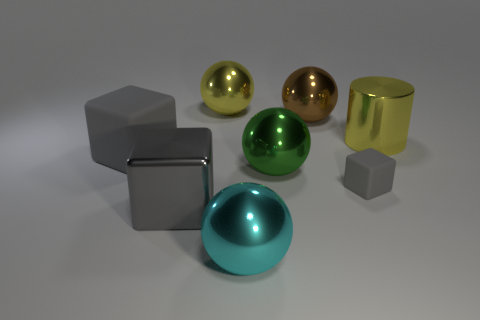How many big metal things are both behind the cyan metal thing and in front of the tiny thing?
Your response must be concise. 1. There is a cylinder that is made of the same material as the green object; what size is it?
Your answer should be very brief. Large. What number of other gray metallic objects are the same shape as the small gray thing?
Ensure brevity in your answer.  1. Are there more big metal cubes in front of the large green ball than small gray rubber things?
Keep it short and to the point. No. There is a large object that is in front of the brown metal object and to the right of the big green metallic sphere; what shape is it?
Ensure brevity in your answer.  Cylinder. Does the shiny cube have the same size as the shiny cylinder?
Keep it short and to the point. Yes. There is a big brown metallic object; what number of metal spheres are in front of it?
Ensure brevity in your answer.  2. Are there the same number of large metal objects on the right side of the brown metal thing and large yellow metallic objects in front of the large cyan shiny object?
Make the answer very short. No. There is a yellow object on the left side of the big yellow cylinder; is its shape the same as the tiny matte thing?
Your answer should be compact. No. Is there anything else that is the same material as the cyan sphere?
Your answer should be compact. Yes. 